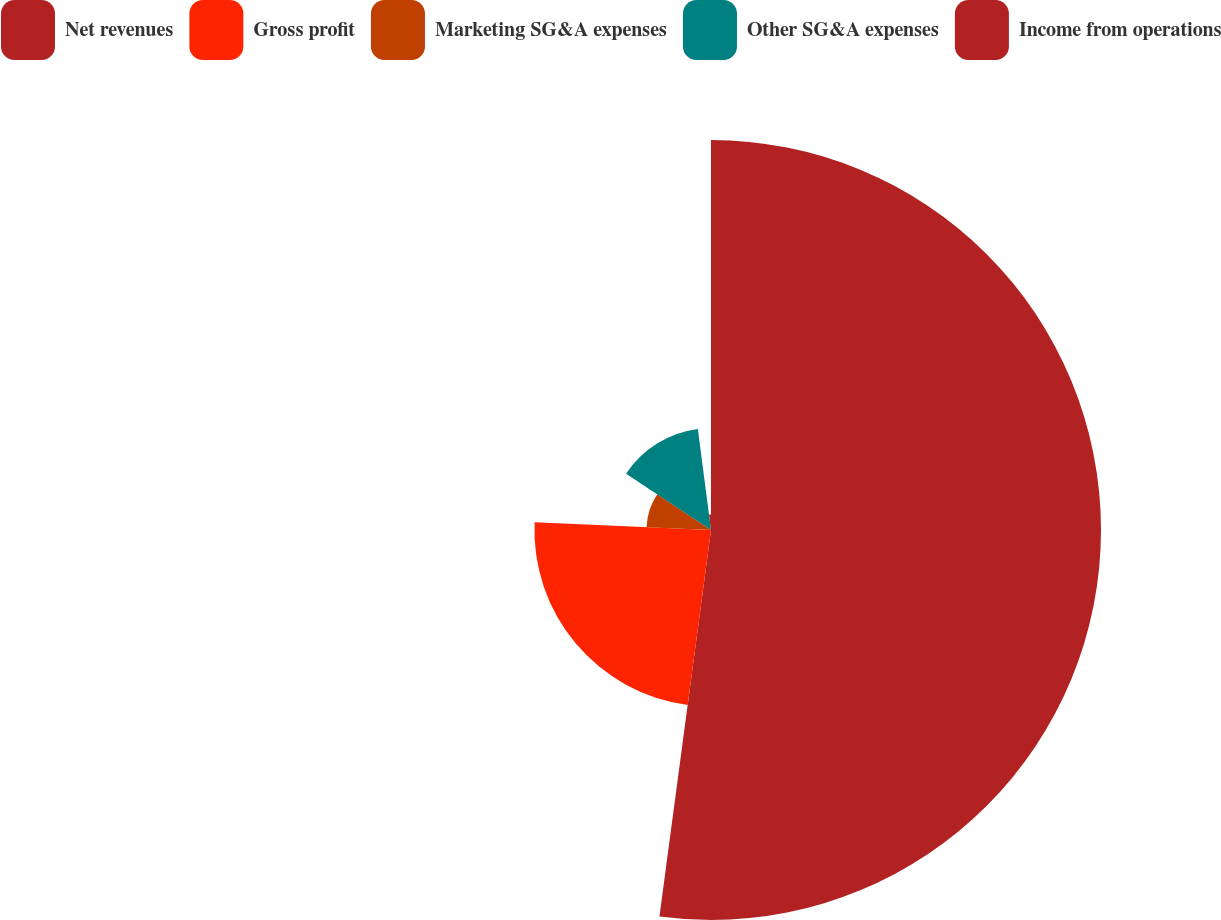Convert chart to OTSL. <chart><loc_0><loc_0><loc_500><loc_500><pie_chart><fcel>Net revenues<fcel>Gross profit<fcel>Marketing SG&A expenses<fcel>Other SG&A expenses<fcel>Income from operations<nl><fcel>52.11%<fcel>23.59%<fcel>8.62%<fcel>13.62%<fcel>2.06%<nl></chart> 